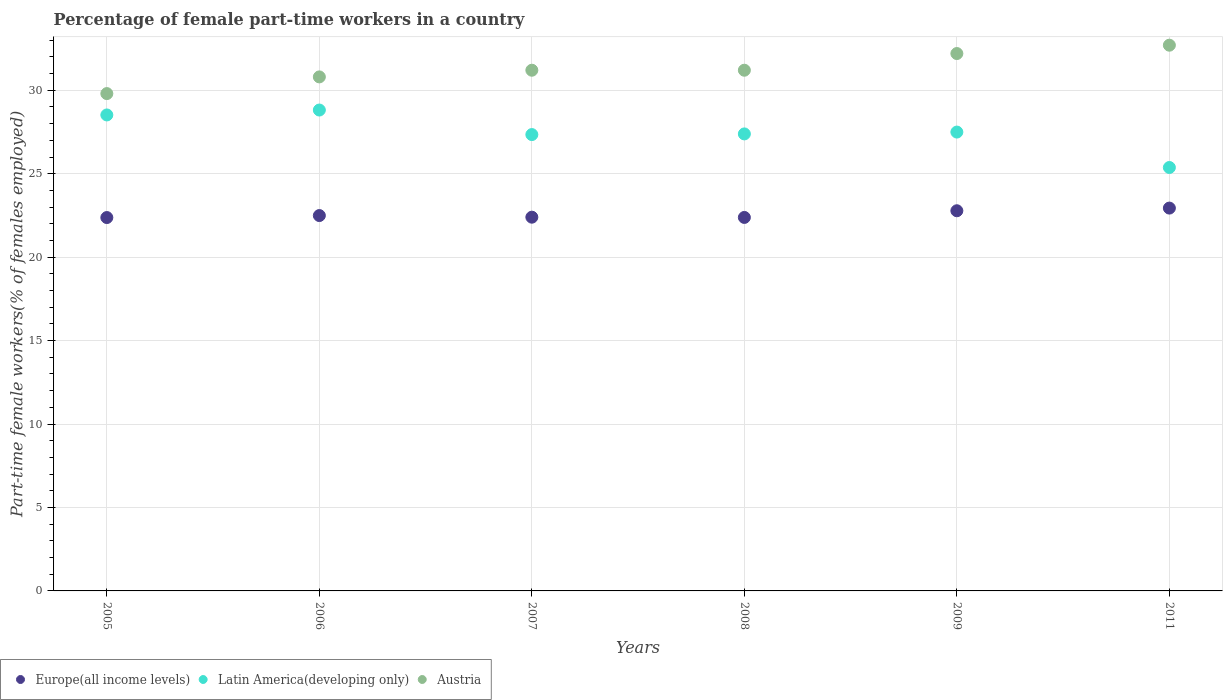Is the number of dotlines equal to the number of legend labels?
Provide a short and direct response. Yes. What is the percentage of female part-time workers in Europe(all income levels) in 2009?
Your response must be concise. 22.78. Across all years, what is the maximum percentage of female part-time workers in Austria?
Your response must be concise. 32.7. Across all years, what is the minimum percentage of female part-time workers in Latin America(developing only)?
Offer a terse response. 25.37. In which year was the percentage of female part-time workers in Austria maximum?
Keep it short and to the point. 2011. What is the total percentage of female part-time workers in Europe(all income levels) in the graph?
Offer a terse response. 135.36. What is the difference between the percentage of female part-time workers in Europe(all income levels) in 2007 and that in 2009?
Your answer should be compact. -0.39. What is the difference between the percentage of female part-time workers in Austria in 2011 and the percentage of female part-time workers in Europe(all income levels) in 2007?
Keep it short and to the point. 10.31. What is the average percentage of female part-time workers in Austria per year?
Your answer should be compact. 31.32. In the year 2011, what is the difference between the percentage of female part-time workers in Austria and percentage of female part-time workers in Europe(all income levels)?
Provide a succinct answer. 9.76. In how many years, is the percentage of female part-time workers in Latin America(developing only) greater than 32 %?
Offer a very short reply. 0. What is the ratio of the percentage of female part-time workers in Latin America(developing only) in 2006 to that in 2008?
Offer a terse response. 1.05. What is the difference between the highest and the second highest percentage of female part-time workers in Europe(all income levels)?
Your answer should be compact. 0.16. What is the difference between the highest and the lowest percentage of female part-time workers in Latin America(developing only)?
Keep it short and to the point. 3.44. Is it the case that in every year, the sum of the percentage of female part-time workers in Austria and percentage of female part-time workers in Europe(all income levels)  is greater than the percentage of female part-time workers in Latin America(developing only)?
Give a very brief answer. Yes. Does the percentage of female part-time workers in Austria monotonically increase over the years?
Your answer should be very brief. No. Is the percentage of female part-time workers in Austria strictly greater than the percentage of female part-time workers in Europe(all income levels) over the years?
Offer a very short reply. Yes. How many dotlines are there?
Your answer should be very brief. 3. Does the graph contain grids?
Provide a succinct answer. Yes. Where does the legend appear in the graph?
Offer a very short reply. Bottom left. What is the title of the graph?
Ensure brevity in your answer.  Percentage of female part-time workers in a country. Does "Latin America(all income levels)" appear as one of the legend labels in the graph?
Your response must be concise. No. What is the label or title of the Y-axis?
Offer a terse response. Part-time female workers(% of females employed). What is the Part-time female workers(% of females employed) in Europe(all income levels) in 2005?
Your answer should be very brief. 22.37. What is the Part-time female workers(% of females employed) of Latin America(developing only) in 2005?
Ensure brevity in your answer.  28.52. What is the Part-time female workers(% of females employed) in Austria in 2005?
Make the answer very short. 29.8. What is the Part-time female workers(% of females employed) in Europe(all income levels) in 2006?
Provide a succinct answer. 22.49. What is the Part-time female workers(% of females employed) in Latin America(developing only) in 2006?
Offer a very short reply. 28.81. What is the Part-time female workers(% of females employed) of Austria in 2006?
Provide a short and direct response. 30.8. What is the Part-time female workers(% of females employed) in Europe(all income levels) in 2007?
Keep it short and to the point. 22.39. What is the Part-time female workers(% of females employed) of Latin America(developing only) in 2007?
Ensure brevity in your answer.  27.34. What is the Part-time female workers(% of females employed) of Austria in 2007?
Your answer should be compact. 31.2. What is the Part-time female workers(% of females employed) in Europe(all income levels) in 2008?
Your answer should be very brief. 22.38. What is the Part-time female workers(% of females employed) in Latin America(developing only) in 2008?
Offer a terse response. 27.38. What is the Part-time female workers(% of females employed) in Austria in 2008?
Make the answer very short. 31.2. What is the Part-time female workers(% of females employed) of Europe(all income levels) in 2009?
Provide a succinct answer. 22.78. What is the Part-time female workers(% of females employed) in Latin America(developing only) in 2009?
Make the answer very short. 27.49. What is the Part-time female workers(% of females employed) of Austria in 2009?
Offer a terse response. 32.2. What is the Part-time female workers(% of females employed) of Europe(all income levels) in 2011?
Your response must be concise. 22.94. What is the Part-time female workers(% of females employed) in Latin America(developing only) in 2011?
Provide a short and direct response. 25.37. What is the Part-time female workers(% of females employed) of Austria in 2011?
Your response must be concise. 32.7. Across all years, what is the maximum Part-time female workers(% of females employed) of Europe(all income levels)?
Keep it short and to the point. 22.94. Across all years, what is the maximum Part-time female workers(% of females employed) in Latin America(developing only)?
Provide a succinct answer. 28.81. Across all years, what is the maximum Part-time female workers(% of females employed) in Austria?
Your response must be concise. 32.7. Across all years, what is the minimum Part-time female workers(% of females employed) of Europe(all income levels)?
Offer a very short reply. 22.37. Across all years, what is the minimum Part-time female workers(% of females employed) of Latin America(developing only)?
Provide a short and direct response. 25.37. Across all years, what is the minimum Part-time female workers(% of females employed) of Austria?
Your answer should be very brief. 29.8. What is the total Part-time female workers(% of females employed) in Europe(all income levels) in the graph?
Your answer should be very brief. 135.36. What is the total Part-time female workers(% of females employed) in Latin America(developing only) in the graph?
Give a very brief answer. 164.93. What is the total Part-time female workers(% of females employed) of Austria in the graph?
Your response must be concise. 187.9. What is the difference between the Part-time female workers(% of females employed) of Europe(all income levels) in 2005 and that in 2006?
Provide a short and direct response. -0.12. What is the difference between the Part-time female workers(% of females employed) in Latin America(developing only) in 2005 and that in 2006?
Offer a terse response. -0.29. What is the difference between the Part-time female workers(% of females employed) of Austria in 2005 and that in 2006?
Offer a terse response. -1. What is the difference between the Part-time female workers(% of females employed) of Europe(all income levels) in 2005 and that in 2007?
Provide a short and direct response. -0.02. What is the difference between the Part-time female workers(% of females employed) in Latin America(developing only) in 2005 and that in 2007?
Keep it short and to the point. 1.18. What is the difference between the Part-time female workers(% of females employed) of Austria in 2005 and that in 2007?
Offer a terse response. -1.4. What is the difference between the Part-time female workers(% of females employed) of Europe(all income levels) in 2005 and that in 2008?
Your response must be concise. -0.01. What is the difference between the Part-time female workers(% of females employed) of Latin America(developing only) in 2005 and that in 2008?
Make the answer very short. 1.14. What is the difference between the Part-time female workers(% of females employed) in Austria in 2005 and that in 2008?
Make the answer very short. -1.4. What is the difference between the Part-time female workers(% of females employed) in Europe(all income levels) in 2005 and that in 2009?
Keep it short and to the point. -0.41. What is the difference between the Part-time female workers(% of females employed) in Latin America(developing only) in 2005 and that in 2009?
Provide a short and direct response. 1.03. What is the difference between the Part-time female workers(% of females employed) in Austria in 2005 and that in 2009?
Offer a very short reply. -2.4. What is the difference between the Part-time female workers(% of females employed) in Europe(all income levels) in 2005 and that in 2011?
Keep it short and to the point. -0.57. What is the difference between the Part-time female workers(% of females employed) of Latin America(developing only) in 2005 and that in 2011?
Offer a very short reply. 3.15. What is the difference between the Part-time female workers(% of females employed) in Europe(all income levels) in 2006 and that in 2007?
Offer a very short reply. 0.1. What is the difference between the Part-time female workers(% of females employed) in Latin America(developing only) in 2006 and that in 2007?
Ensure brevity in your answer.  1.47. What is the difference between the Part-time female workers(% of females employed) in Europe(all income levels) in 2006 and that in 2008?
Your answer should be compact. 0.11. What is the difference between the Part-time female workers(% of females employed) of Latin America(developing only) in 2006 and that in 2008?
Ensure brevity in your answer.  1.43. What is the difference between the Part-time female workers(% of females employed) in Europe(all income levels) in 2006 and that in 2009?
Give a very brief answer. -0.29. What is the difference between the Part-time female workers(% of females employed) in Latin America(developing only) in 2006 and that in 2009?
Ensure brevity in your answer.  1.32. What is the difference between the Part-time female workers(% of females employed) in Austria in 2006 and that in 2009?
Offer a terse response. -1.4. What is the difference between the Part-time female workers(% of females employed) of Europe(all income levels) in 2006 and that in 2011?
Your response must be concise. -0.45. What is the difference between the Part-time female workers(% of females employed) of Latin America(developing only) in 2006 and that in 2011?
Make the answer very short. 3.44. What is the difference between the Part-time female workers(% of females employed) in Europe(all income levels) in 2007 and that in 2008?
Your answer should be very brief. 0.02. What is the difference between the Part-time female workers(% of females employed) in Latin America(developing only) in 2007 and that in 2008?
Provide a succinct answer. -0.04. What is the difference between the Part-time female workers(% of females employed) in Austria in 2007 and that in 2008?
Your answer should be very brief. 0. What is the difference between the Part-time female workers(% of females employed) of Europe(all income levels) in 2007 and that in 2009?
Ensure brevity in your answer.  -0.39. What is the difference between the Part-time female workers(% of females employed) of Austria in 2007 and that in 2009?
Ensure brevity in your answer.  -1. What is the difference between the Part-time female workers(% of females employed) in Europe(all income levels) in 2007 and that in 2011?
Make the answer very short. -0.54. What is the difference between the Part-time female workers(% of females employed) in Latin America(developing only) in 2007 and that in 2011?
Provide a succinct answer. 1.97. What is the difference between the Part-time female workers(% of females employed) of Austria in 2007 and that in 2011?
Your answer should be very brief. -1.5. What is the difference between the Part-time female workers(% of females employed) of Europe(all income levels) in 2008 and that in 2009?
Offer a terse response. -0.4. What is the difference between the Part-time female workers(% of females employed) in Latin America(developing only) in 2008 and that in 2009?
Provide a succinct answer. -0.11. What is the difference between the Part-time female workers(% of females employed) of Europe(all income levels) in 2008 and that in 2011?
Provide a succinct answer. -0.56. What is the difference between the Part-time female workers(% of females employed) in Latin America(developing only) in 2008 and that in 2011?
Keep it short and to the point. 2.01. What is the difference between the Part-time female workers(% of females employed) of Austria in 2008 and that in 2011?
Your answer should be very brief. -1.5. What is the difference between the Part-time female workers(% of females employed) of Europe(all income levels) in 2009 and that in 2011?
Keep it short and to the point. -0.16. What is the difference between the Part-time female workers(% of females employed) in Latin America(developing only) in 2009 and that in 2011?
Ensure brevity in your answer.  2.12. What is the difference between the Part-time female workers(% of females employed) in Europe(all income levels) in 2005 and the Part-time female workers(% of females employed) in Latin America(developing only) in 2006?
Offer a terse response. -6.44. What is the difference between the Part-time female workers(% of females employed) in Europe(all income levels) in 2005 and the Part-time female workers(% of females employed) in Austria in 2006?
Offer a terse response. -8.43. What is the difference between the Part-time female workers(% of females employed) of Latin America(developing only) in 2005 and the Part-time female workers(% of females employed) of Austria in 2006?
Give a very brief answer. -2.28. What is the difference between the Part-time female workers(% of females employed) in Europe(all income levels) in 2005 and the Part-time female workers(% of females employed) in Latin America(developing only) in 2007?
Offer a terse response. -4.97. What is the difference between the Part-time female workers(% of females employed) in Europe(all income levels) in 2005 and the Part-time female workers(% of females employed) in Austria in 2007?
Your answer should be very brief. -8.83. What is the difference between the Part-time female workers(% of females employed) of Latin America(developing only) in 2005 and the Part-time female workers(% of females employed) of Austria in 2007?
Your response must be concise. -2.68. What is the difference between the Part-time female workers(% of females employed) in Europe(all income levels) in 2005 and the Part-time female workers(% of females employed) in Latin America(developing only) in 2008?
Your answer should be compact. -5.01. What is the difference between the Part-time female workers(% of females employed) of Europe(all income levels) in 2005 and the Part-time female workers(% of females employed) of Austria in 2008?
Offer a very short reply. -8.83. What is the difference between the Part-time female workers(% of females employed) of Latin America(developing only) in 2005 and the Part-time female workers(% of females employed) of Austria in 2008?
Your answer should be compact. -2.68. What is the difference between the Part-time female workers(% of females employed) of Europe(all income levels) in 2005 and the Part-time female workers(% of females employed) of Latin America(developing only) in 2009?
Ensure brevity in your answer.  -5.12. What is the difference between the Part-time female workers(% of females employed) in Europe(all income levels) in 2005 and the Part-time female workers(% of females employed) in Austria in 2009?
Your answer should be compact. -9.83. What is the difference between the Part-time female workers(% of females employed) of Latin America(developing only) in 2005 and the Part-time female workers(% of females employed) of Austria in 2009?
Give a very brief answer. -3.68. What is the difference between the Part-time female workers(% of females employed) in Europe(all income levels) in 2005 and the Part-time female workers(% of females employed) in Latin America(developing only) in 2011?
Give a very brief answer. -3. What is the difference between the Part-time female workers(% of females employed) in Europe(all income levels) in 2005 and the Part-time female workers(% of females employed) in Austria in 2011?
Give a very brief answer. -10.33. What is the difference between the Part-time female workers(% of females employed) of Latin America(developing only) in 2005 and the Part-time female workers(% of females employed) of Austria in 2011?
Provide a short and direct response. -4.18. What is the difference between the Part-time female workers(% of females employed) in Europe(all income levels) in 2006 and the Part-time female workers(% of females employed) in Latin America(developing only) in 2007?
Your answer should be compact. -4.85. What is the difference between the Part-time female workers(% of females employed) in Europe(all income levels) in 2006 and the Part-time female workers(% of females employed) in Austria in 2007?
Your answer should be compact. -8.71. What is the difference between the Part-time female workers(% of females employed) in Latin America(developing only) in 2006 and the Part-time female workers(% of females employed) in Austria in 2007?
Give a very brief answer. -2.39. What is the difference between the Part-time female workers(% of females employed) in Europe(all income levels) in 2006 and the Part-time female workers(% of females employed) in Latin America(developing only) in 2008?
Your answer should be very brief. -4.89. What is the difference between the Part-time female workers(% of females employed) in Europe(all income levels) in 2006 and the Part-time female workers(% of females employed) in Austria in 2008?
Make the answer very short. -8.71. What is the difference between the Part-time female workers(% of females employed) in Latin America(developing only) in 2006 and the Part-time female workers(% of females employed) in Austria in 2008?
Your response must be concise. -2.39. What is the difference between the Part-time female workers(% of females employed) in Europe(all income levels) in 2006 and the Part-time female workers(% of females employed) in Latin America(developing only) in 2009?
Your answer should be compact. -5. What is the difference between the Part-time female workers(% of females employed) of Europe(all income levels) in 2006 and the Part-time female workers(% of females employed) of Austria in 2009?
Provide a succinct answer. -9.71. What is the difference between the Part-time female workers(% of females employed) of Latin America(developing only) in 2006 and the Part-time female workers(% of females employed) of Austria in 2009?
Keep it short and to the point. -3.39. What is the difference between the Part-time female workers(% of females employed) in Europe(all income levels) in 2006 and the Part-time female workers(% of females employed) in Latin America(developing only) in 2011?
Offer a very short reply. -2.88. What is the difference between the Part-time female workers(% of females employed) in Europe(all income levels) in 2006 and the Part-time female workers(% of females employed) in Austria in 2011?
Your answer should be very brief. -10.21. What is the difference between the Part-time female workers(% of females employed) in Latin America(developing only) in 2006 and the Part-time female workers(% of females employed) in Austria in 2011?
Give a very brief answer. -3.89. What is the difference between the Part-time female workers(% of females employed) in Europe(all income levels) in 2007 and the Part-time female workers(% of females employed) in Latin America(developing only) in 2008?
Make the answer very short. -4.99. What is the difference between the Part-time female workers(% of females employed) of Europe(all income levels) in 2007 and the Part-time female workers(% of females employed) of Austria in 2008?
Make the answer very short. -8.81. What is the difference between the Part-time female workers(% of females employed) in Latin America(developing only) in 2007 and the Part-time female workers(% of females employed) in Austria in 2008?
Give a very brief answer. -3.86. What is the difference between the Part-time female workers(% of females employed) in Europe(all income levels) in 2007 and the Part-time female workers(% of females employed) in Latin America(developing only) in 2009?
Make the answer very short. -5.1. What is the difference between the Part-time female workers(% of females employed) of Europe(all income levels) in 2007 and the Part-time female workers(% of females employed) of Austria in 2009?
Make the answer very short. -9.81. What is the difference between the Part-time female workers(% of females employed) in Latin America(developing only) in 2007 and the Part-time female workers(% of females employed) in Austria in 2009?
Your answer should be very brief. -4.86. What is the difference between the Part-time female workers(% of females employed) of Europe(all income levels) in 2007 and the Part-time female workers(% of females employed) of Latin America(developing only) in 2011?
Keep it short and to the point. -2.98. What is the difference between the Part-time female workers(% of females employed) of Europe(all income levels) in 2007 and the Part-time female workers(% of females employed) of Austria in 2011?
Provide a succinct answer. -10.31. What is the difference between the Part-time female workers(% of females employed) in Latin America(developing only) in 2007 and the Part-time female workers(% of females employed) in Austria in 2011?
Provide a short and direct response. -5.36. What is the difference between the Part-time female workers(% of females employed) of Europe(all income levels) in 2008 and the Part-time female workers(% of females employed) of Latin America(developing only) in 2009?
Provide a short and direct response. -5.12. What is the difference between the Part-time female workers(% of females employed) of Europe(all income levels) in 2008 and the Part-time female workers(% of females employed) of Austria in 2009?
Provide a short and direct response. -9.82. What is the difference between the Part-time female workers(% of females employed) in Latin America(developing only) in 2008 and the Part-time female workers(% of females employed) in Austria in 2009?
Provide a short and direct response. -4.82. What is the difference between the Part-time female workers(% of females employed) in Europe(all income levels) in 2008 and the Part-time female workers(% of females employed) in Latin America(developing only) in 2011?
Your response must be concise. -2.99. What is the difference between the Part-time female workers(% of females employed) of Europe(all income levels) in 2008 and the Part-time female workers(% of females employed) of Austria in 2011?
Offer a very short reply. -10.32. What is the difference between the Part-time female workers(% of females employed) in Latin America(developing only) in 2008 and the Part-time female workers(% of females employed) in Austria in 2011?
Ensure brevity in your answer.  -5.32. What is the difference between the Part-time female workers(% of females employed) of Europe(all income levels) in 2009 and the Part-time female workers(% of females employed) of Latin America(developing only) in 2011?
Keep it short and to the point. -2.59. What is the difference between the Part-time female workers(% of females employed) of Europe(all income levels) in 2009 and the Part-time female workers(% of females employed) of Austria in 2011?
Your answer should be very brief. -9.92. What is the difference between the Part-time female workers(% of females employed) in Latin America(developing only) in 2009 and the Part-time female workers(% of females employed) in Austria in 2011?
Offer a very short reply. -5.21. What is the average Part-time female workers(% of females employed) of Europe(all income levels) per year?
Offer a terse response. 22.56. What is the average Part-time female workers(% of females employed) of Latin America(developing only) per year?
Give a very brief answer. 27.49. What is the average Part-time female workers(% of females employed) in Austria per year?
Ensure brevity in your answer.  31.32. In the year 2005, what is the difference between the Part-time female workers(% of females employed) in Europe(all income levels) and Part-time female workers(% of females employed) in Latin America(developing only)?
Provide a short and direct response. -6.15. In the year 2005, what is the difference between the Part-time female workers(% of females employed) of Europe(all income levels) and Part-time female workers(% of females employed) of Austria?
Give a very brief answer. -7.43. In the year 2005, what is the difference between the Part-time female workers(% of females employed) of Latin America(developing only) and Part-time female workers(% of females employed) of Austria?
Give a very brief answer. -1.28. In the year 2006, what is the difference between the Part-time female workers(% of females employed) in Europe(all income levels) and Part-time female workers(% of females employed) in Latin America(developing only)?
Provide a short and direct response. -6.32. In the year 2006, what is the difference between the Part-time female workers(% of females employed) of Europe(all income levels) and Part-time female workers(% of females employed) of Austria?
Provide a short and direct response. -8.31. In the year 2006, what is the difference between the Part-time female workers(% of females employed) of Latin America(developing only) and Part-time female workers(% of females employed) of Austria?
Ensure brevity in your answer.  -1.99. In the year 2007, what is the difference between the Part-time female workers(% of females employed) of Europe(all income levels) and Part-time female workers(% of females employed) of Latin America(developing only)?
Offer a terse response. -4.95. In the year 2007, what is the difference between the Part-time female workers(% of females employed) in Europe(all income levels) and Part-time female workers(% of females employed) in Austria?
Provide a succinct answer. -8.81. In the year 2007, what is the difference between the Part-time female workers(% of females employed) of Latin America(developing only) and Part-time female workers(% of females employed) of Austria?
Give a very brief answer. -3.86. In the year 2008, what is the difference between the Part-time female workers(% of females employed) in Europe(all income levels) and Part-time female workers(% of females employed) in Latin America(developing only)?
Make the answer very short. -5. In the year 2008, what is the difference between the Part-time female workers(% of females employed) of Europe(all income levels) and Part-time female workers(% of females employed) of Austria?
Keep it short and to the point. -8.82. In the year 2008, what is the difference between the Part-time female workers(% of females employed) of Latin America(developing only) and Part-time female workers(% of females employed) of Austria?
Offer a very short reply. -3.82. In the year 2009, what is the difference between the Part-time female workers(% of females employed) in Europe(all income levels) and Part-time female workers(% of females employed) in Latin America(developing only)?
Offer a terse response. -4.71. In the year 2009, what is the difference between the Part-time female workers(% of females employed) of Europe(all income levels) and Part-time female workers(% of females employed) of Austria?
Give a very brief answer. -9.42. In the year 2009, what is the difference between the Part-time female workers(% of females employed) of Latin America(developing only) and Part-time female workers(% of females employed) of Austria?
Ensure brevity in your answer.  -4.71. In the year 2011, what is the difference between the Part-time female workers(% of females employed) in Europe(all income levels) and Part-time female workers(% of females employed) in Latin America(developing only)?
Your response must be concise. -2.43. In the year 2011, what is the difference between the Part-time female workers(% of females employed) in Europe(all income levels) and Part-time female workers(% of females employed) in Austria?
Your response must be concise. -9.76. In the year 2011, what is the difference between the Part-time female workers(% of females employed) of Latin America(developing only) and Part-time female workers(% of females employed) of Austria?
Your response must be concise. -7.33. What is the ratio of the Part-time female workers(% of females employed) in Europe(all income levels) in 2005 to that in 2006?
Your response must be concise. 0.99. What is the ratio of the Part-time female workers(% of females employed) of Latin America(developing only) in 2005 to that in 2006?
Offer a very short reply. 0.99. What is the ratio of the Part-time female workers(% of females employed) of Austria in 2005 to that in 2006?
Offer a terse response. 0.97. What is the ratio of the Part-time female workers(% of females employed) of Europe(all income levels) in 2005 to that in 2007?
Make the answer very short. 1. What is the ratio of the Part-time female workers(% of females employed) of Latin America(developing only) in 2005 to that in 2007?
Provide a succinct answer. 1.04. What is the ratio of the Part-time female workers(% of females employed) of Austria in 2005 to that in 2007?
Make the answer very short. 0.96. What is the ratio of the Part-time female workers(% of females employed) of Europe(all income levels) in 2005 to that in 2008?
Give a very brief answer. 1. What is the ratio of the Part-time female workers(% of females employed) in Latin America(developing only) in 2005 to that in 2008?
Your response must be concise. 1.04. What is the ratio of the Part-time female workers(% of females employed) of Austria in 2005 to that in 2008?
Keep it short and to the point. 0.96. What is the ratio of the Part-time female workers(% of females employed) in Europe(all income levels) in 2005 to that in 2009?
Your answer should be very brief. 0.98. What is the ratio of the Part-time female workers(% of females employed) of Latin America(developing only) in 2005 to that in 2009?
Provide a succinct answer. 1.04. What is the ratio of the Part-time female workers(% of females employed) of Austria in 2005 to that in 2009?
Your answer should be compact. 0.93. What is the ratio of the Part-time female workers(% of females employed) of Europe(all income levels) in 2005 to that in 2011?
Provide a short and direct response. 0.98. What is the ratio of the Part-time female workers(% of females employed) in Latin America(developing only) in 2005 to that in 2011?
Make the answer very short. 1.12. What is the ratio of the Part-time female workers(% of females employed) in Austria in 2005 to that in 2011?
Provide a short and direct response. 0.91. What is the ratio of the Part-time female workers(% of females employed) of Europe(all income levels) in 2006 to that in 2007?
Provide a succinct answer. 1. What is the ratio of the Part-time female workers(% of females employed) of Latin America(developing only) in 2006 to that in 2007?
Offer a very short reply. 1.05. What is the ratio of the Part-time female workers(% of females employed) of Austria in 2006 to that in 2007?
Keep it short and to the point. 0.99. What is the ratio of the Part-time female workers(% of females employed) of Europe(all income levels) in 2006 to that in 2008?
Provide a succinct answer. 1. What is the ratio of the Part-time female workers(% of females employed) of Latin America(developing only) in 2006 to that in 2008?
Your answer should be very brief. 1.05. What is the ratio of the Part-time female workers(% of females employed) in Austria in 2006 to that in 2008?
Make the answer very short. 0.99. What is the ratio of the Part-time female workers(% of females employed) of Europe(all income levels) in 2006 to that in 2009?
Keep it short and to the point. 0.99. What is the ratio of the Part-time female workers(% of females employed) in Latin America(developing only) in 2006 to that in 2009?
Offer a very short reply. 1.05. What is the ratio of the Part-time female workers(% of females employed) in Austria in 2006 to that in 2009?
Offer a terse response. 0.96. What is the ratio of the Part-time female workers(% of females employed) in Europe(all income levels) in 2006 to that in 2011?
Your response must be concise. 0.98. What is the ratio of the Part-time female workers(% of females employed) in Latin America(developing only) in 2006 to that in 2011?
Offer a terse response. 1.14. What is the ratio of the Part-time female workers(% of females employed) in Austria in 2006 to that in 2011?
Keep it short and to the point. 0.94. What is the ratio of the Part-time female workers(% of females employed) in Europe(all income levels) in 2007 to that in 2009?
Offer a very short reply. 0.98. What is the ratio of the Part-time female workers(% of females employed) of Austria in 2007 to that in 2009?
Your answer should be compact. 0.97. What is the ratio of the Part-time female workers(% of females employed) in Europe(all income levels) in 2007 to that in 2011?
Your answer should be compact. 0.98. What is the ratio of the Part-time female workers(% of females employed) of Latin America(developing only) in 2007 to that in 2011?
Keep it short and to the point. 1.08. What is the ratio of the Part-time female workers(% of females employed) in Austria in 2007 to that in 2011?
Your answer should be very brief. 0.95. What is the ratio of the Part-time female workers(% of females employed) in Europe(all income levels) in 2008 to that in 2009?
Give a very brief answer. 0.98. What is the ratio of the Part-time female workers(% of females employed) in Latin America(developing only) in 2008 to that in 2009?
Your answer should be very brief. 1. What is the ratio of the Part-time female workers(% of females employed) in Austria in 2008 to that in 2009?
Give a very brief answer. 0.97. What is the ratio of the Part-time female workers(% of females employed) of Europe(all income levels) in 2008 to that in 2011?
Keep it short and to the point. 0.98. What is the ratio of the Part-time female workers(% of females employed) in Latin America(developing only) in 2008 to that in 2011?
Offer a very short reply. 1.08. What is the ratio of the Part-time female workers(% of females employed) of Austria in 2008 to that in 2011?
Provide a short and direct response. 0.95. What is the ratio of the Part-time female workers(% of females employed) in Europe(all income levels) in 2009 to that in 2011?
Your response must be concise. 0.99. What is the ratio of the Part-time female workers(% of females employed) in Latin America(developing only) in 2009 to that in 2011?
Your answer should be very brief. 1.08. What is the ratio of the Part-time female workers(% of females employed) of Austria in 2009 to that in 2011?
Provide a succinct answer. 0.98. What is the difference between the highest and the second highest Part-time female workers(% of females employed) of Europe(all income levels)?
Keep it short and to the point. 0.16. What is the difference between the highest and the second highest Part-time female workers(% of females employed) in Latin America(developing only)?
Keep it short and to the point. 0.29. What is the difference between the highest and the lowest Part-time female workers(% of females employed) in Europe(all income levels)?
Ensure brevity in your answer.  0.57. What is the difference between the highest and the lowest Part-time female workers(% of females employed) of Latin America(developing only)?
Offer a very short reply. 3.44. 